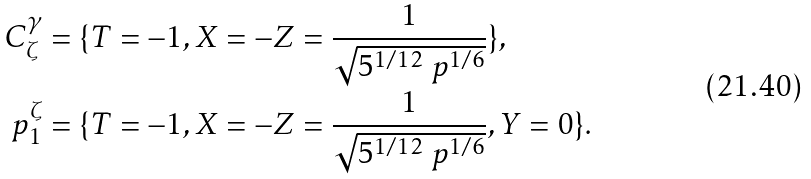<formula> <loc_0><loc_0><loc_500><loc_500>C _ { \zeta } ^ { \gamma } & = \{ T = - 1 , X = - Z = \frac { 1 } { \sqrt { 5 ^ { 1 / 1 2 } \ p ^ { 1 / 6 } } } \} , \\ p _ { 1 } ^ { \zeta } & = \{ T = - 1 , X = - Z = \frac { 1 } { \sqrt { 5 ^ { 1 / 1 2 } \ p ^ { 1 / 6 } } } , Y = 0 \} .</formula> 